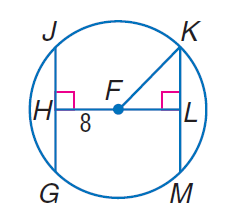Answer the mathemtical geometry problem and directly provide the correct option letter.
Question: In \odot F, F H \cong F L and F K = 17. Find J H.
Choices: A: 15 B: 16 C: 17 D: 30 A 